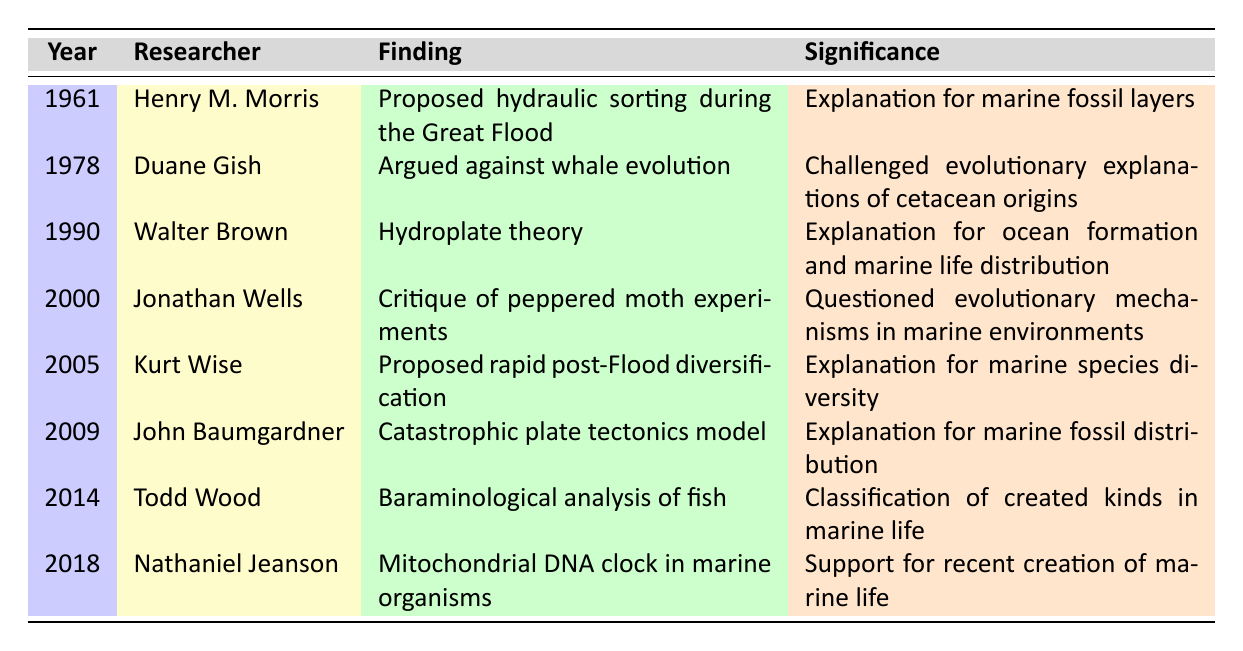What year did Henry M. Morris propose his findings? According to the table, Henry M. Morris made his proposal in the year 1961.
Answer: 1961 Which researcher argued against whale evolution? The table indicates that Duane Gish argued against whale evolution.
Answer: Duane Gish What significance is associated with the hydroplate theory by Walter Brown? The significance of Walter Brown's hydroplate theory is noted in the table as an explanation for ocean formation and marine life distribution.
Answer: Explanation for ocean formation and marine life distribution How many researchers made significant findings in the 2000s? By counting the entries, we find that there are five researchers listed from the years 2000 to 2009.
Answer: 5 Who proposed a rapid post-Flood diversification in marine species and in what year? The table shows that Kurt Wise proposed rapid post-Flood diversification in marine species in the year 2005.
Answer: Kurt Wise, 2005 Is the finding related to mitochondrial DNA clock in marine organisms supporting recent creation true? The table confirms that Nathaniel Jeanson's finding about mitochondrial DNA clock does support the recent creation of marine life.
Answer: Yes Which finding is associated with the year 2014 and what is its significance? The table states that Todd Wood's finding in 2014 is related to baraminological analysis of fish, and it signifies the classification of created kinds in marine life.
Answer: Baraminological analysis of fish; classification of created kinds in marine life What is the average year of all the findings listed in the table? To find the average, sum the years: (1961 + 1978 + 1990 + 2000 + 2005 + 2009 + 2014 + 2018) = 15975. There are 8 entries, so the average year is 15975 / 8 = 1996.875, which rounds to 1997.
Answer: 1997 Which two findings were made in the years before 2000? The table lists Henry M. Morris's proposal in 1961 and Duane Gish's argument in 1978, both of which were before the year 2000.
Answer: 1961 and 1978 Summarize the significance of John's Baumgardner's research finding. According to the table, John Baumgardner's finding of a catastrophic plate tectonics model is significant as it provides an explanation for marine fossil distribution.
Answer: Explanation for marine fossil distribution 